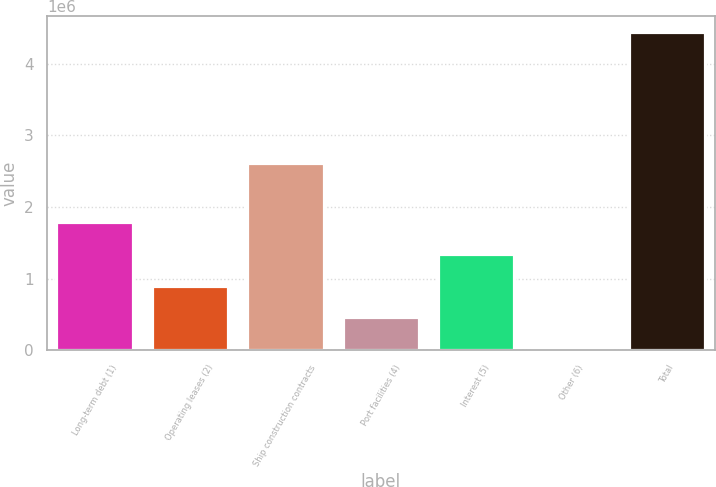Convert chart to OTSL. <chart><loc_0><loc_0><loc_500><loc_500><bar_chart><fcel>Long-term debt (1)<fcel>Operating leases (2)<fcel>Ship construction contracts<fcel>Port facilities (4)<fcel>Interest (5)<fcel>Other (6)<fcel>Total<nl><fcel>1.78558e+06<fcel>900969<fcel>2.6169e+06<fcel>458662<fcel>1.34328e+06<fcel>16355<fcel>4.43943e+06<nl></chart> 